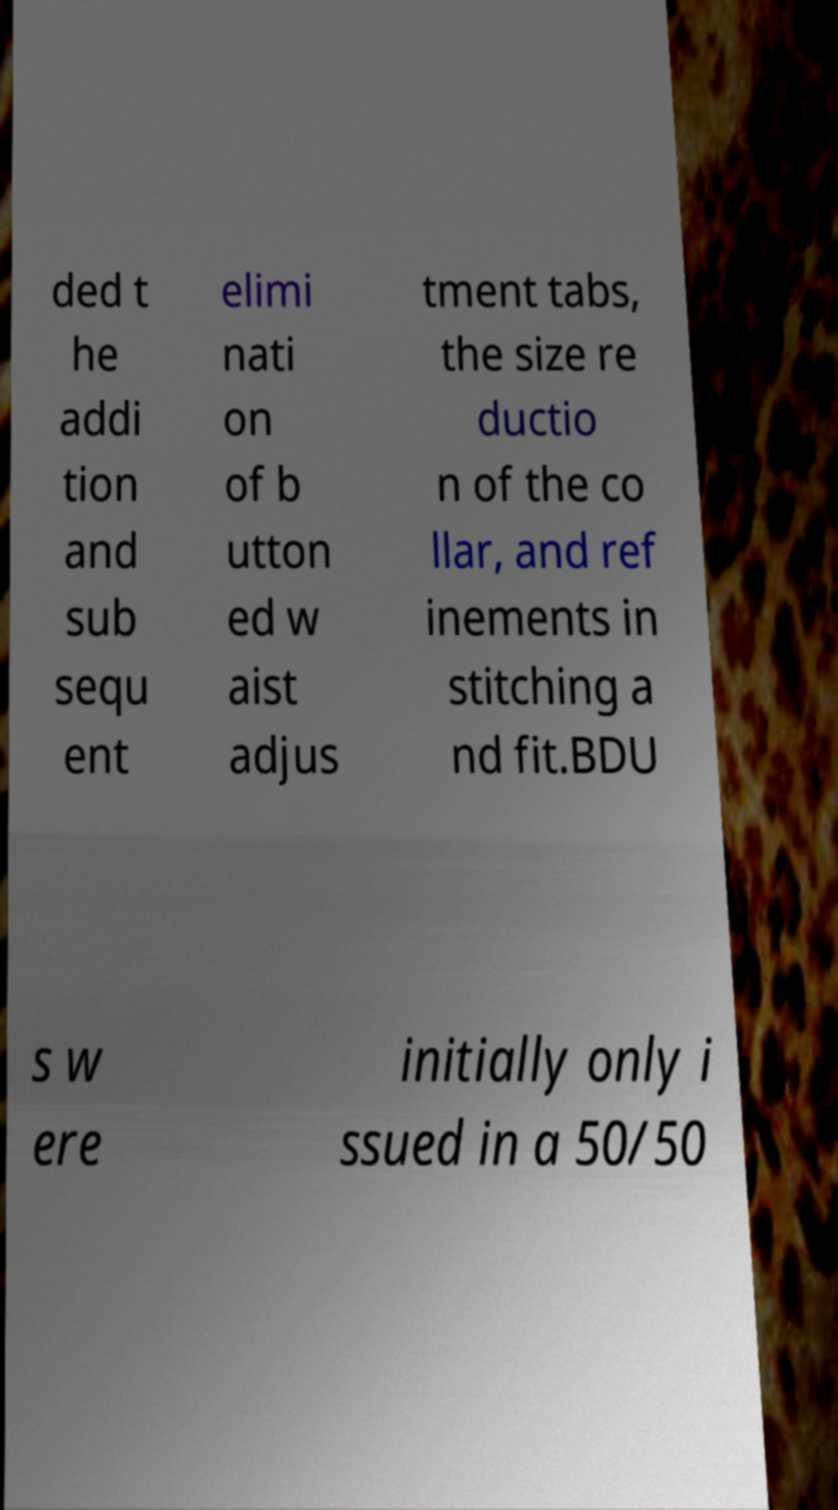Please read and relay the text visible in this image. What does it say? ded t he addi tion and sub sequ ent elimi nati on of b utton ed w aist adjus tment tabs, the size re ductio n of the co llar, and ref inements in stitching a nd fit.BDU s w ere initially only i ssued in a 50/50 